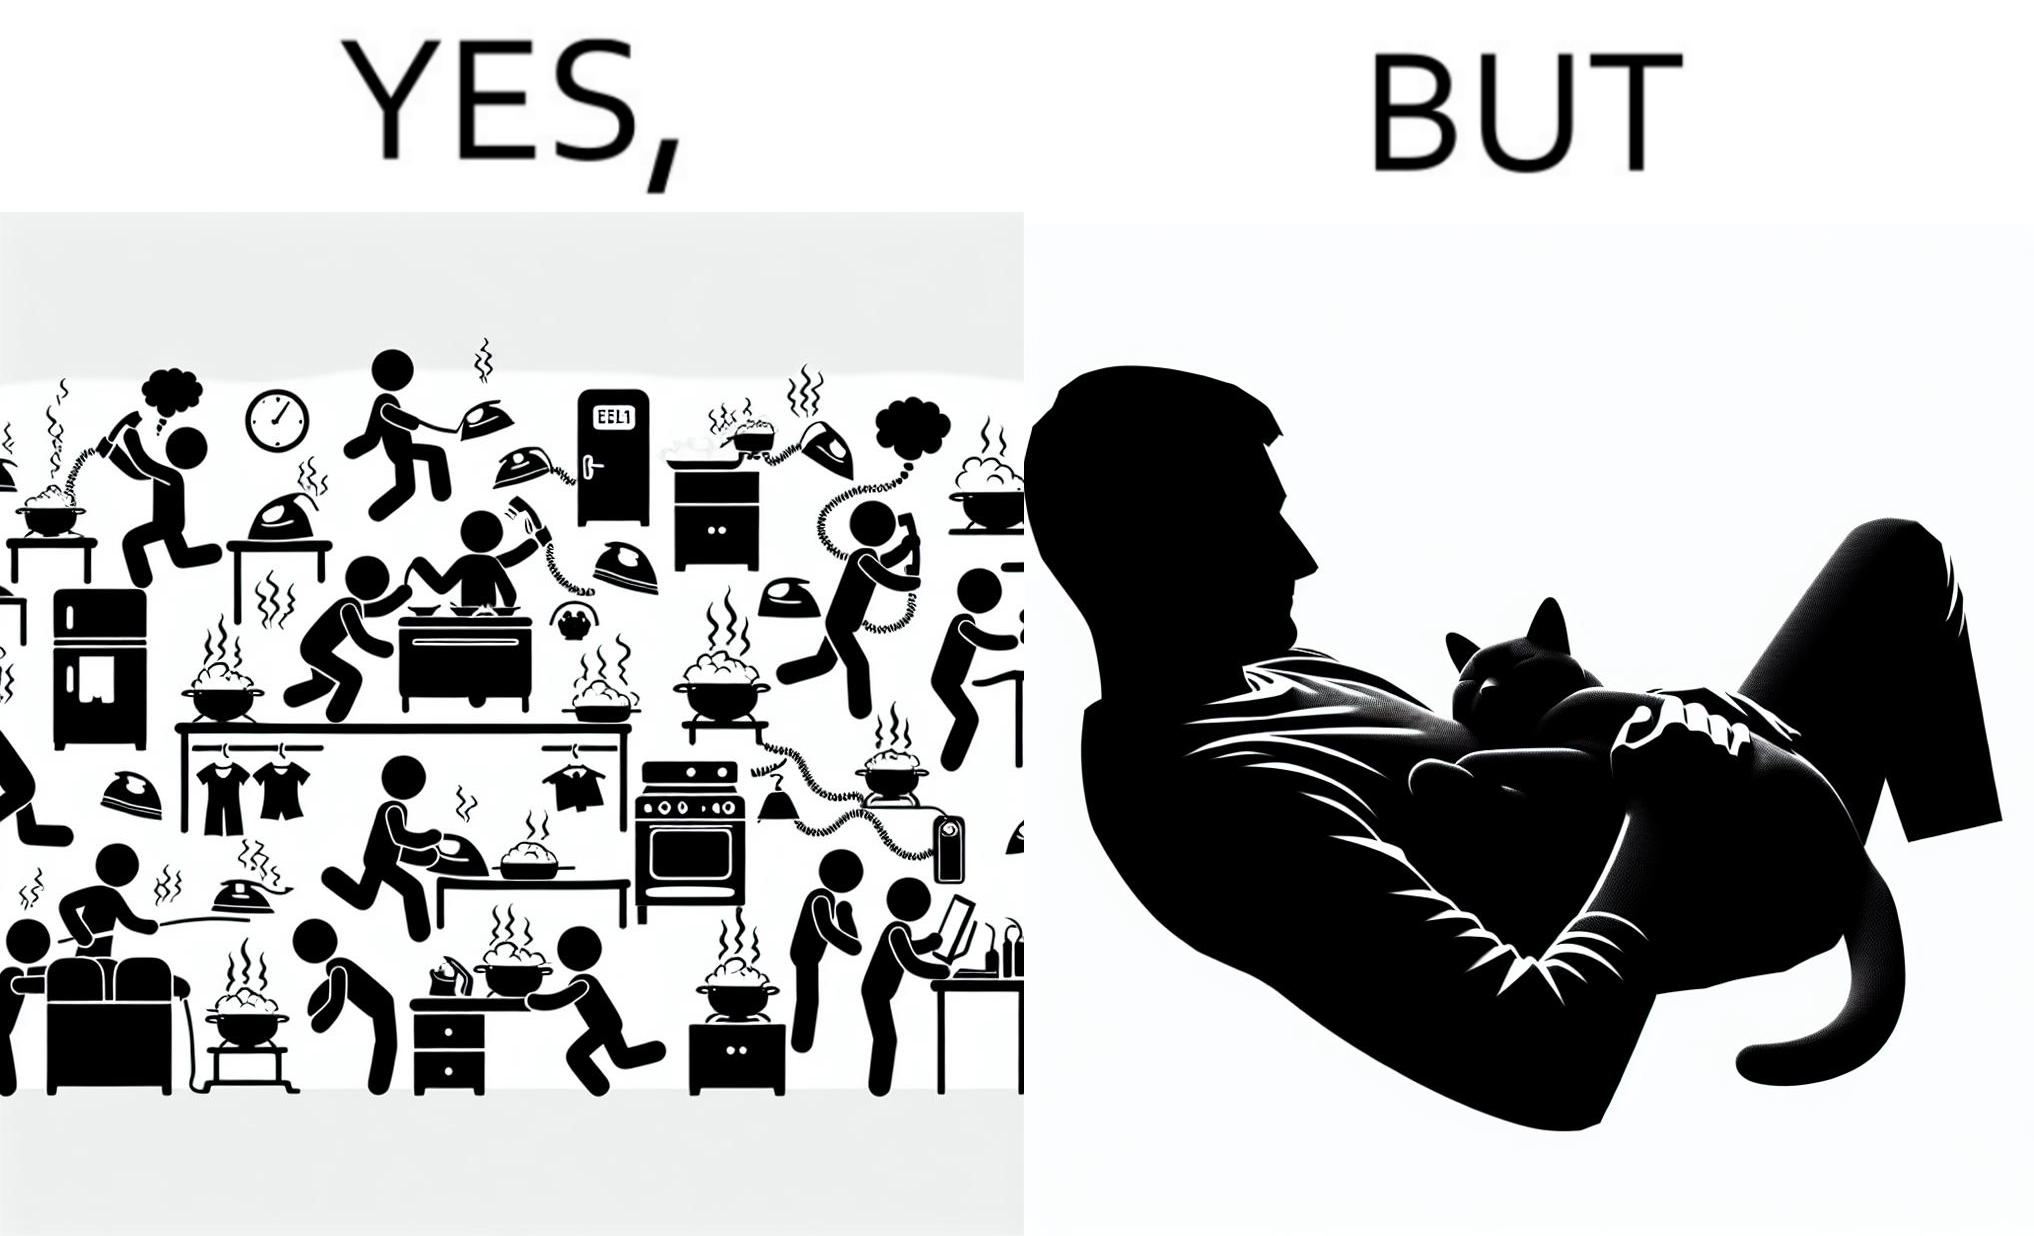Describe what you see in this image. the irony in this image is that people ignore all the chaos around them and get distracted by a cat. 